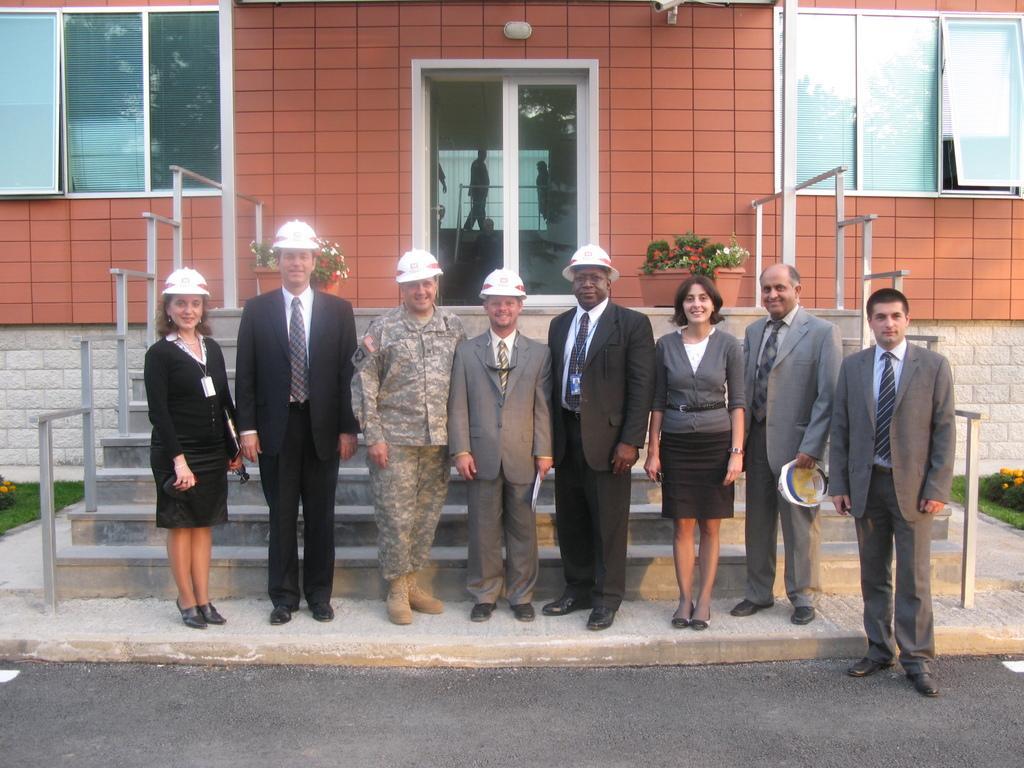Could you give a brief overview of what you see in this image? In this image in the center there are some persons standing, and some of them are wearing helmets. And in the background there is a building, glass doors, windows, railing and staircase. At the bottom there is road, and on the right side and left side there is grass and some flowers and in the center there are flower pots and plants. Through the glass doors we could see a reflection of some persons and a railing. 